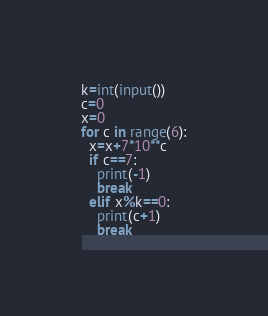Convert code to text. <code><loc_0><loc_0><loc_500><loc_500><_Python_>k=int(input())
c=0
x=0
for c in range(6):
  x=x+7*10**c
  if c==7:
  	print(-1)
    break
  elif x%k==0:
    print(c+1)
    break
</code> 